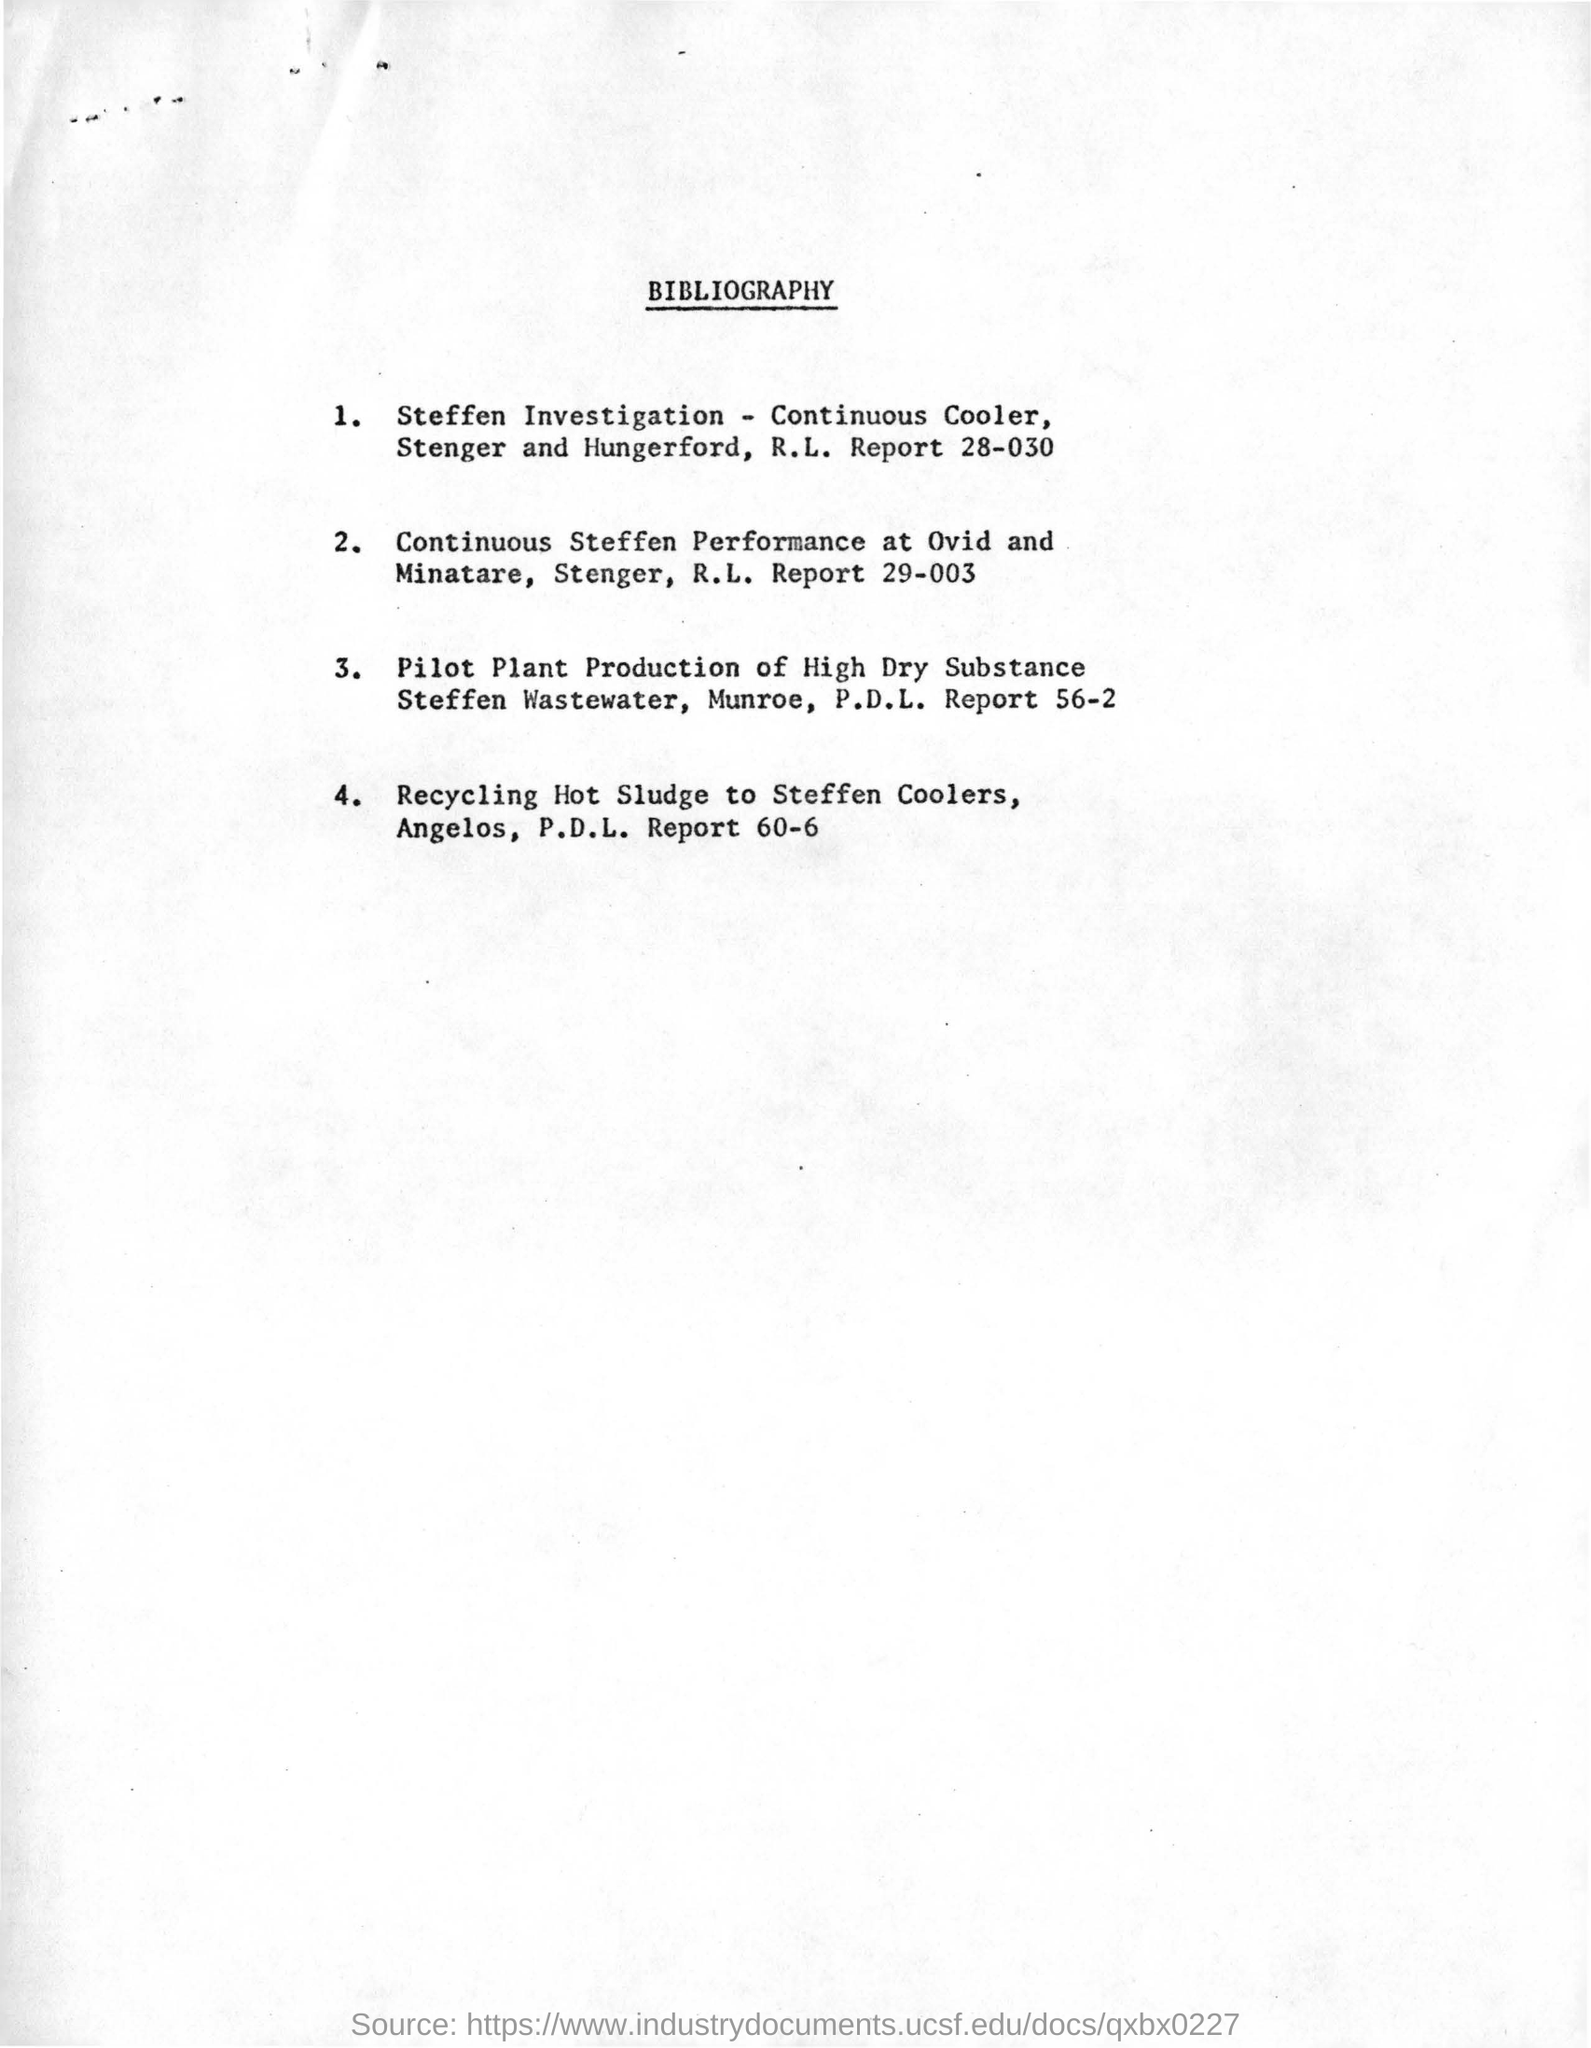What is the title of this document?
Offer a very short reply. Bibliography. 